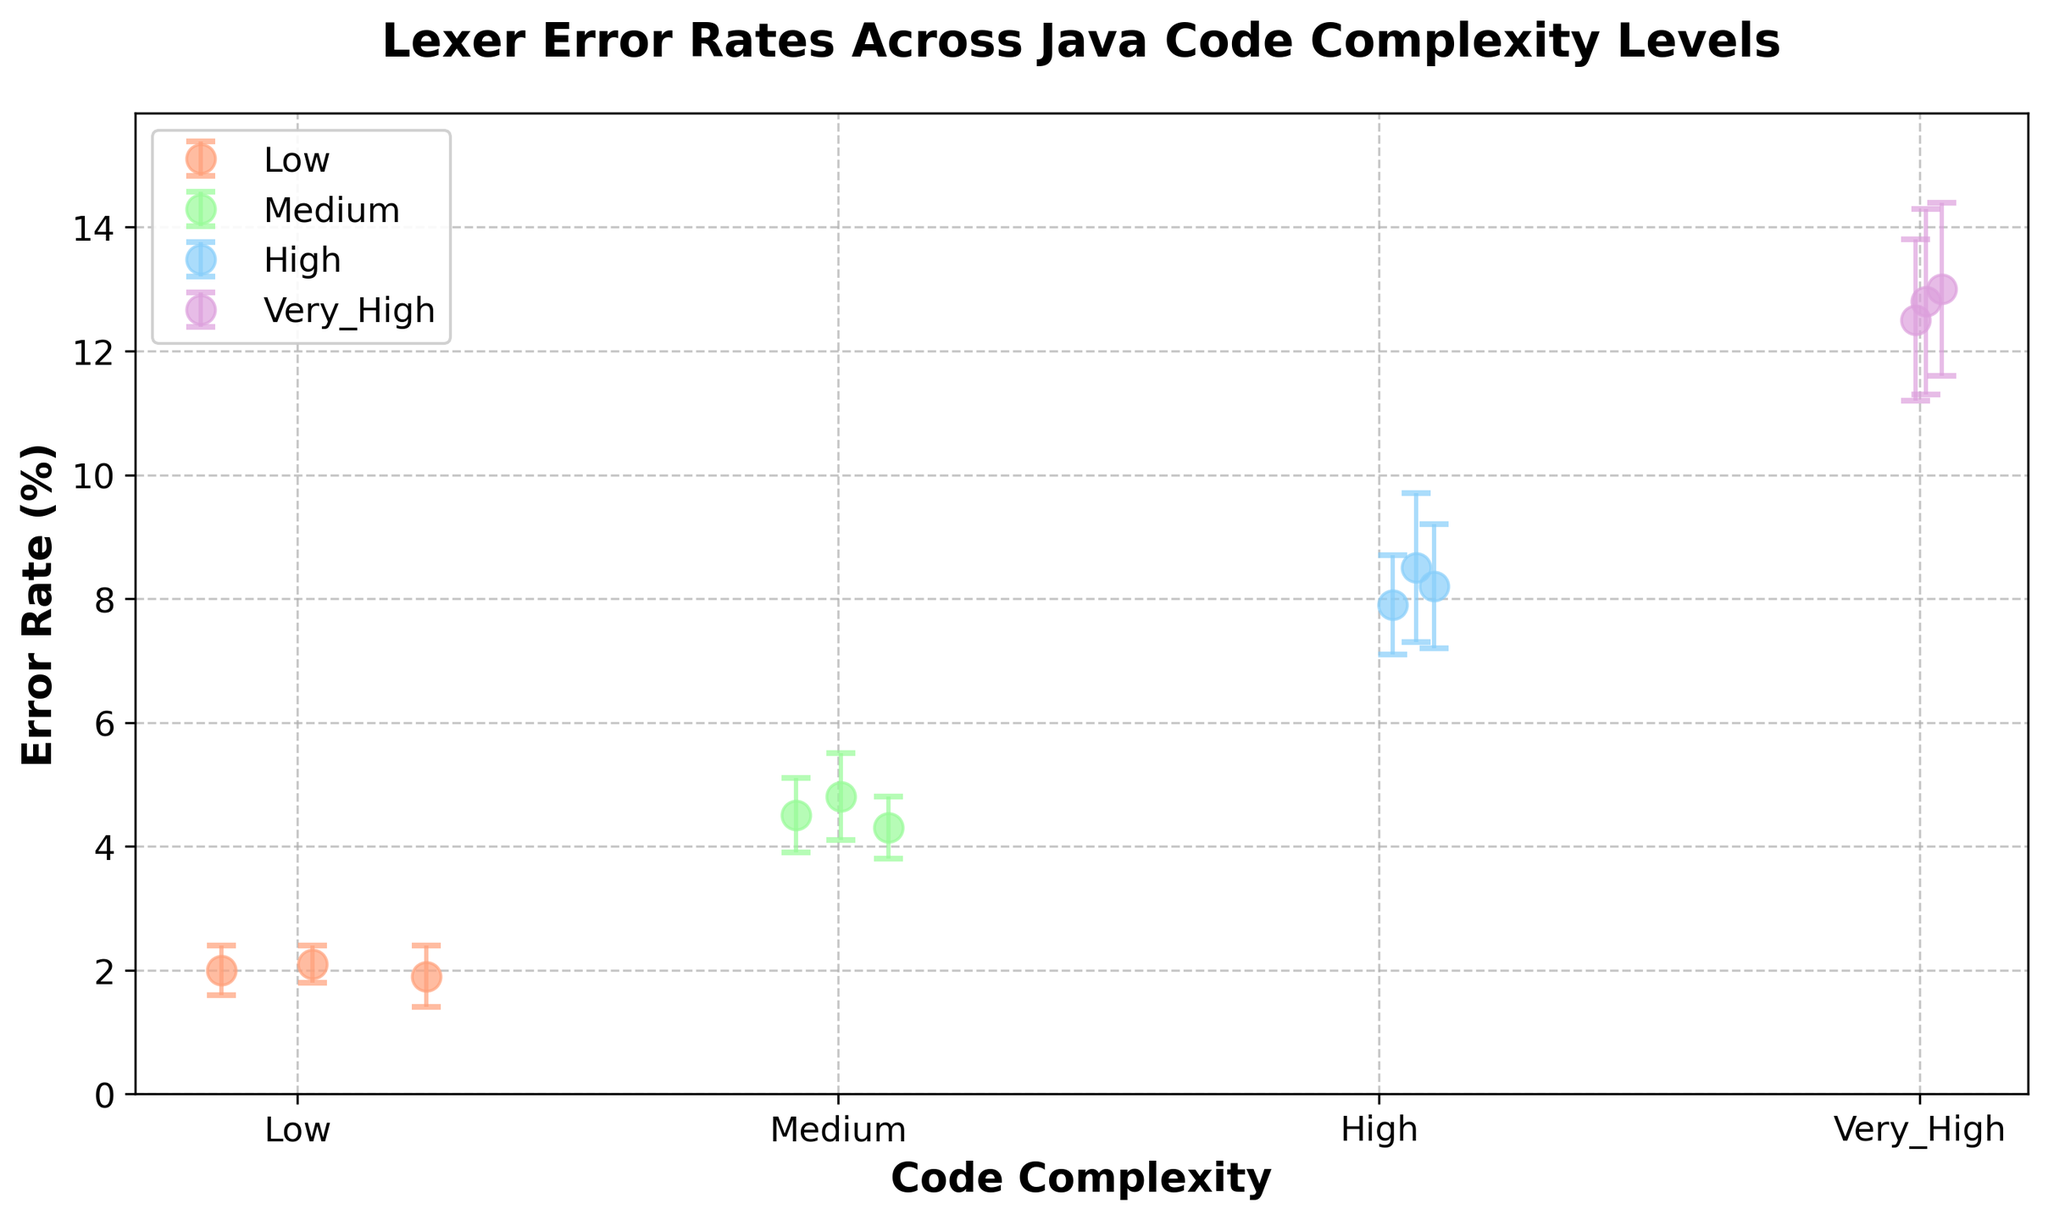What is the title of the scatter plot? The title of the scatter plot is shown at the top, and it describes what the plot is about.
Answer: Lexer Error Rates Across Java Code Complexity Levels What are the four levels of code complexity displayed on the x-axis? The x-axis labels represent the different levels of code complexity included in the data.
Answer: Low, Medium, High, Very_High What is the range of error rates for the 'Low' complexity level? By looking at the y-values of the points for 'Low' complexity, we can see the minimum and maximum error rates. The points range from 1.9 to 2.1.
Answer: 1.9 to 2.1 Which complexity level has the highest average error rate? To determine the highest average error rate, compare the middle point (average) of the error bars for each complexity level. 'Very_High' shows the highest values around 12.8.
Answer: Very_High Which color represents 'High' complexity level? By matching the legend with the data points, the color for 'High' complexity is identified.
Answer: Light Blue What is the approximate error rate for the 'Medium' complexity level? By observing the data point's positions along the y-axis for the 'Medium' complexity, the approximate average can be seen around 4.5 to 4.8.
Answer: 4.5 to 4.8 How spread out are the error rates for the 'Very_High' complexity level? Look at the length of the error bars. For 'Very_High', they are quite large, indicating significant spread.
Answer: Significantly spread out Which complexity level shows the lowest variation in error rates? By comparing the error bars for each complexity level, 'Low' has the shortest error bars indicating the least variation.
Answer: Low Which complexity levels have overlapping error rates, making it hard to distinguish their average rates? Compare error bars to see where they overlap completely or significantly, thereby making their averages indistinguishable. The 'Medium' and 'High' levels show overlapping error bars.
Answer: Medium and High 